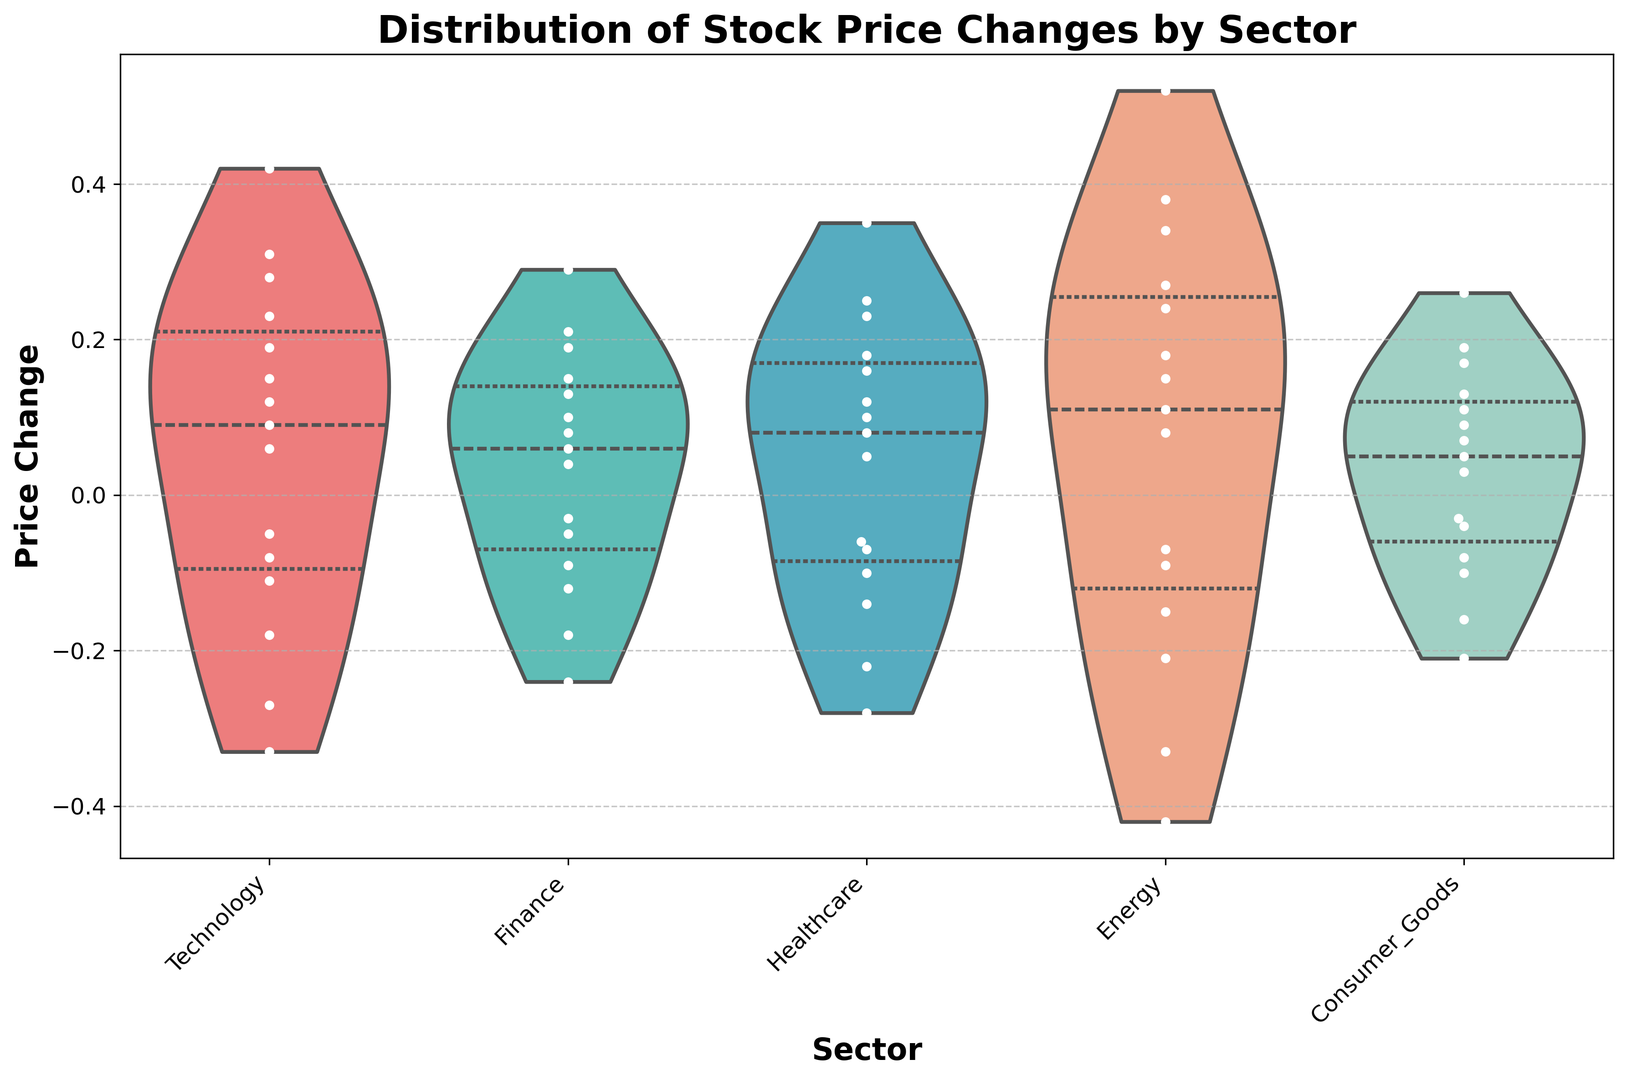What's the median price change for the Energy sector? The median is the middle value of the sorted price changes. For the Energy sector, arrange the price changes: -0.42, -0.33, -0.21, -0.15, -0.09, -0.07, 0.08, 0.11, 0.15, 0.18, 0.24, 0.27, 0.34, 0.38, 0.52. The median value is 0.15.
Answer: 0.15 Which sector has the highest positive outlier in price change? To determine the highest positive outlier, look at the upper-extreme ends of the violin plots. The highest upward outlier is in the Energy sector, reaching up to 0.52.
Answer: Energy What is the interquartile range (IQR) for the Finance sector? The IQR is the range between the first quartile (Q1) and third quartile (Q3). Based on the inner quartile through the violins, locate Q1 and Q3 for Finance and calculate the difference: approximately 0.06 (Q3) − (-0.09) (Q1) = 0.15.
Answer: 0.15 Which sector has the widest distribution of price changes? The width of the violin plot indicates the distribution range. The Energy sector has the widest distribution, ranging from approximately -0.42 to 0.52.
Answer: Energy How does the price change distribution for Technology compare to Consumer Goods? Compare the violin plots of both sectors. The Technology sector shows slightly more extensive variation in both directions compared to Consumer Goods, indicating higher volatility in Technology.
Answer: Technology has higher volatility Is there any sector that shows a symmetric distribution of price changes? Symmetric distributions will be bell-shaped and equal on both sides. The Finance sector's violin plot appears to be symmetric around its median.
Answer: Finance What is the range of positive price changes for Healthcare? Identify the maximum and minimum values of positive price changes in Healthcare. The highest positive change is 0.35, and the lowest is around 0.05. The range is 0.35 - 0.05 = 0.30.
Answer: 0.30 Which sector has the smallest negative price change? Identify the smallest negative price change by looking for the lowest downward point in the violin plots. The smallest negative price change is in Consumer Goods at around -0.21.
Answer: Consumer Goods What are the mean price changes for the Consumer Goods sector? Use the white points indicating the mean of the price changes in each sector's violin plot. The mean price change for Consumer Goods is roughly located around 0.07.
Answer: 0.07 In which sector is the central density of the price changes the highest? The central density is highest where the violin plot is thickest around the center. Finance shows a high central density around the median compared to other sectors.
Answer: Finance 